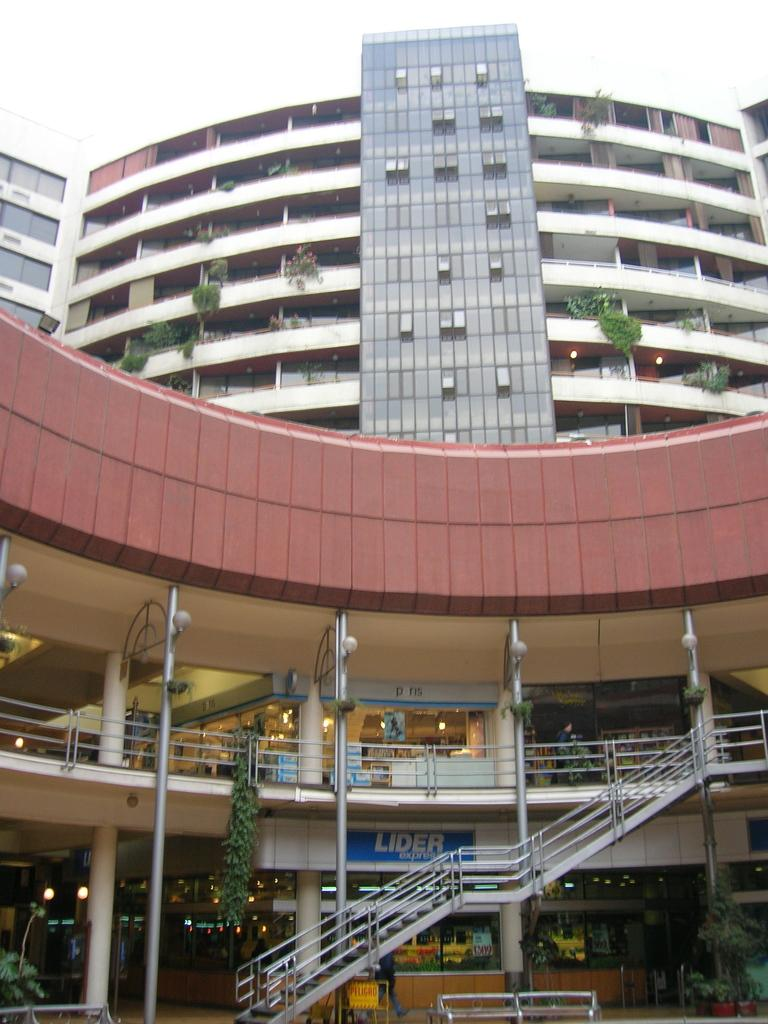Provide a one-sentence caption for the provided image. The front of an outside shopping mall with the name Lider on the bottom floor. 